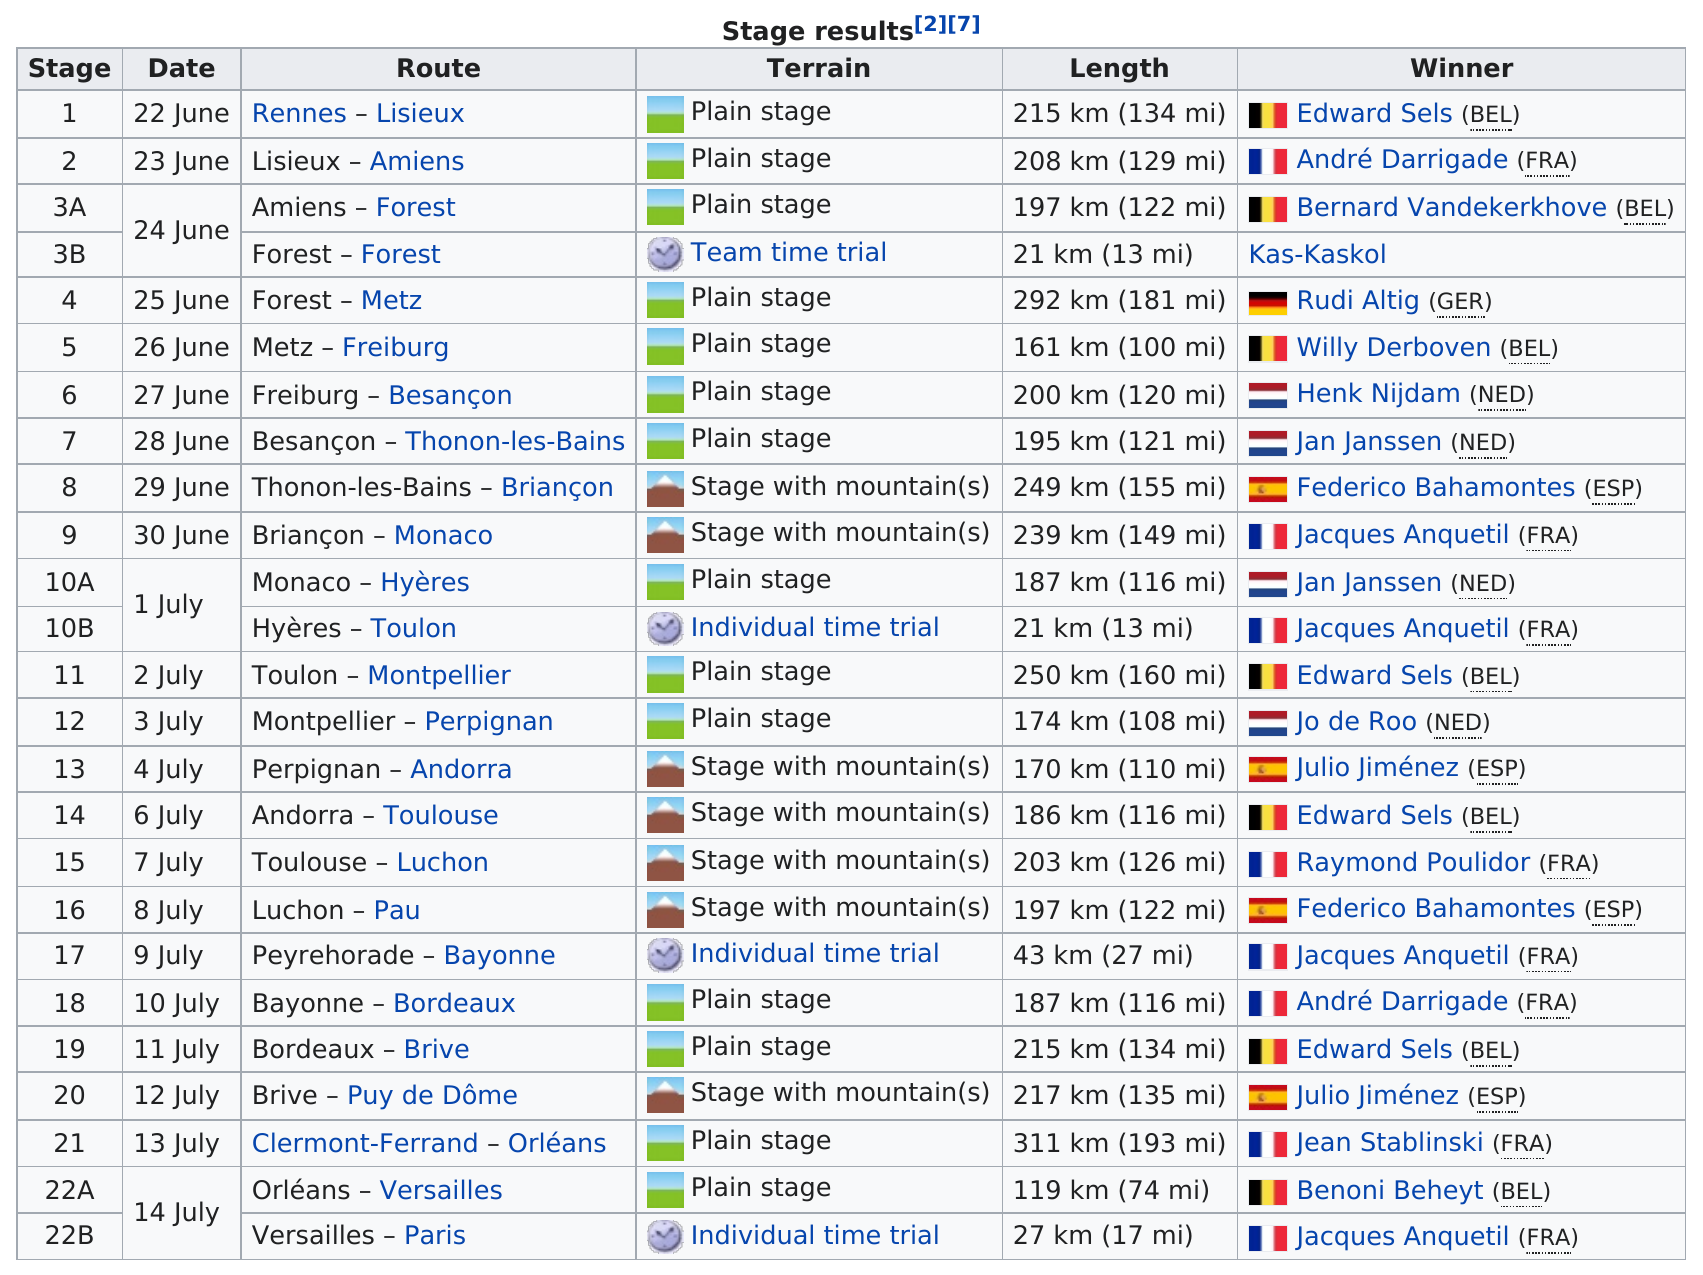Highlight a few significant elements in this photo. The Freiburg - Besançon route featured plain stage terrain and was used on June 27. Clermont-Ferrand to Orléans is the route with the longest distance. The route between Rennes and Lisieux was used first. Five different countries have won at least one stage in the 1964 Tour de France. The stage was won by Rudi Altig, and it lasted for a total of 292 kilometers (181 miles). 